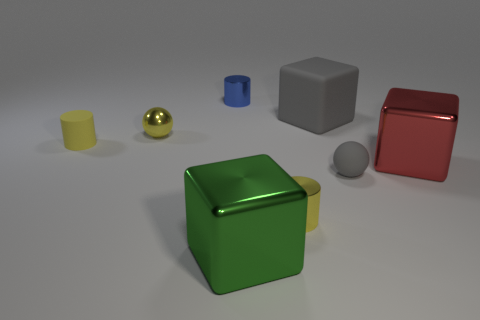There is a rubber object that is on the right side of the yellow sphere and in front of the rubber cube; what shape is it?
Offer a very short reply. Sphere. Is the number of large rubber cylinders less than the number of tiny blue shiny cylinders?
Make the answer very short. Yes. Are any yellow metallic spheres visible?
Provide a succinct answer. Yes. How many other objects are the same size as the blue thing?
Provide a succinct answer. 4. Are the blue cylinder and the tiny yellow thing in front of the gray rubber ball made of the same material?
Offer a very short reply. Yes. Are there an equal number of tiny rubber cylinders behind the big red metal thing and gray matte spheres that are to the left of the small yellow metal ball?
Keep it short and to the point. No. What is the red block made of?
Give a very brief answer. Metal. The other matte ball that is the same size as the yellow ball is what color?
Your answer should be very brief. Gray. Is there a matte cylinder that is right of the large metallic cube on the left side of the large gray block?
Offer a very short reply. No. What number of cylinders are big objects or tiny shiny objects?
Ensure brevity in your answer.  2. 